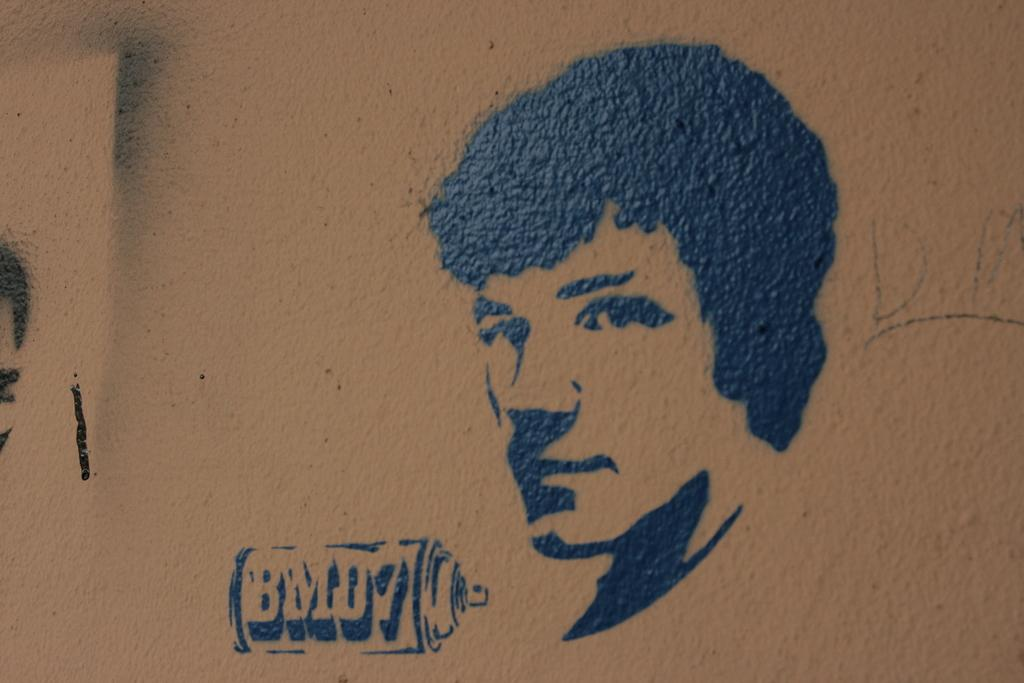What is present on the wall in the image? There is a person's painting on the wall. Can you describe the other artwork in the image? There is another painting on the left side of the image. How many paintings can be seen in the image? There are two paintings visible in the image. What type of alarm is going off in the image? There is no alarm present in the image. Can you describe the actor's performance in the image? There is no actor present in the image. 